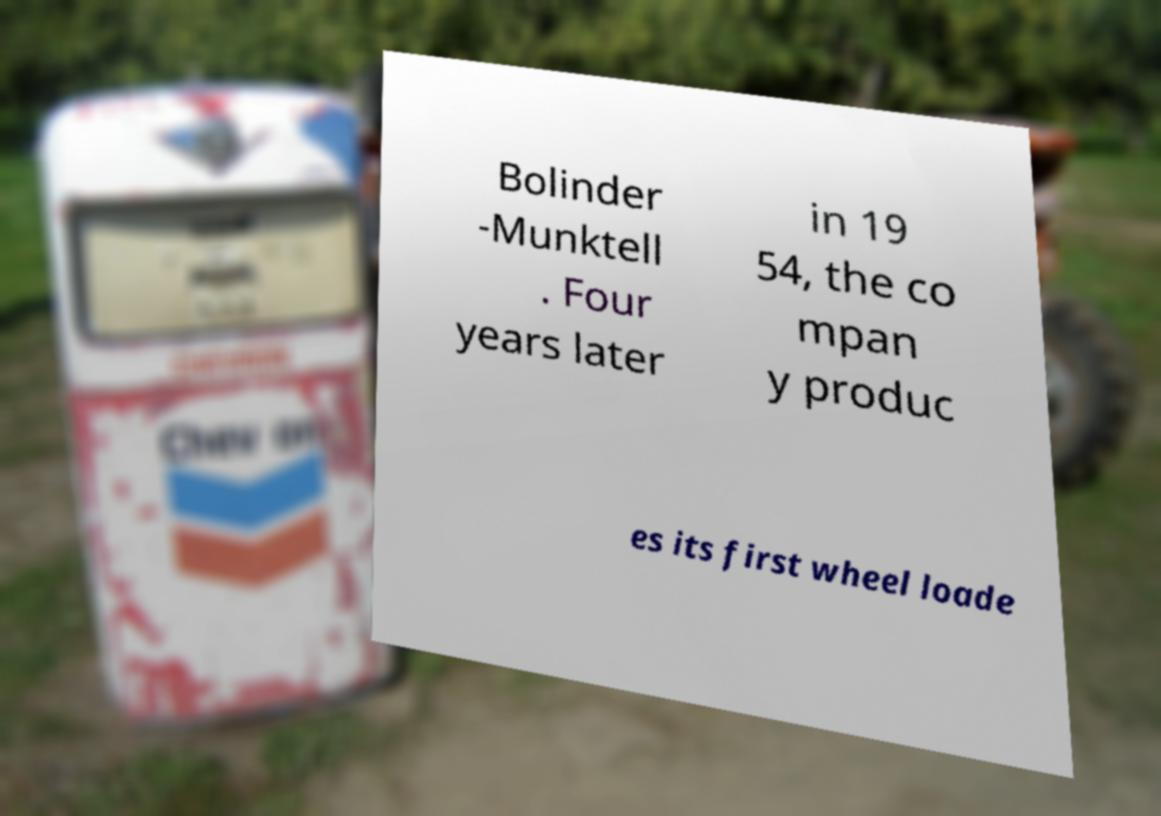Can you read and provide the text displayed in the image?This photo seems to have some interesting text. Can you extract and type it out for me? Bolinder -Munktell . Four years later in 19 54, the co mpan y produc es its first wheel loade 